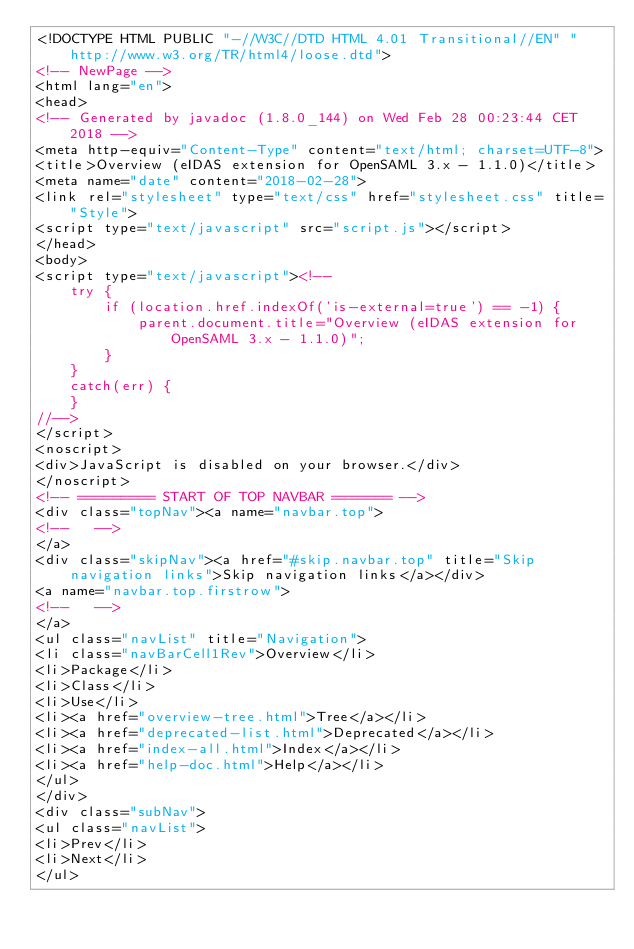<code> <loc_0><loc_0><loc_500><loc_500><_HTML_><!DOCTYPE HTML PUBLIC "-//W3C//DTD HTML 4.01 Transitional//EN" "http://www.w3.org/TR/html4/loose.dtd">
<!-- NewPage -->
<html lang="en">
<head>
<!-- Generated by javadoc (1.8.0_144) on Wed Feb 28 00:23:44 CET 2018 -->
<meta http-equiv="Content-Type" content="text/html; charset=UTF-8">
<title>Overview (eIDAS extension for OpenSAML 3.x - 1.1.0)</title>
<meta name="date" content="2018-02-28">
<link rel="stylesheet" type="text/css" href="stylesheet.css" title="Style">
<script type="text/javascript" src="script.js"></script>
</head>
<body>
<script type="text/javascript"><!--
    try {
        if (location.href.indexOf('is-external=true') == -1) {
            parent.document.title="Overview (eIDAS extension for OpenSAML 3.x - 1.1.0)";
        }
    }
    catch(err) {
    }
//-->
</script>
<noscript>
<div>JavaScript is disabled on your browser.</div>
</noscript>
<!-- ========= START OF TOP NAVBAR ======= -->
<div class="topNav"><a name="navbar.top">
<!--   -->
</a>
<div class="skipNav"><a href="#skip.navbar.top" title="Skip navigation links">Skip navigation links</a></div>
<a name="navbar.top.firstrow">
<!--   -->
</a>
<ul class="navList" title="Navigation">
<li class="navBarCell1Rev">Overview</li>
<li>Package</li>
<li>Class</li>
<li>Use</li>
<li><a href="overview-tree.html">Tree</a></li>
<li><a href="deprecated-list.html">Deprecated</a></li>
<li><a href="index-all.html">Index</a></li>
<li><a href="help-doc.html">Help</a></li>
</ul>
</div>
<div class="subNav">
<ul class="navList">
<li>Prev</li>
<li>Next</li>
</ul></code> 